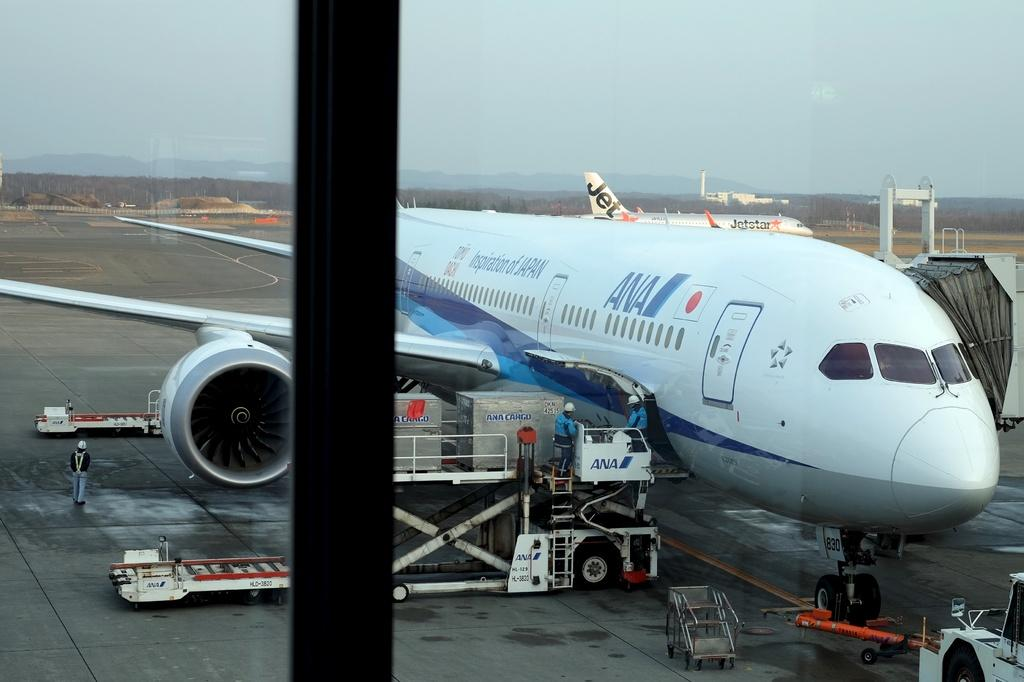What object is present in the image that can show reflections? There is a mirror in the image. What can be seen in the reflection of the mirror? The reflection of planes is visible in the mirror. What else is happening in the image besides the mirror and its reflection? There are people standing around in the image. How is the growth of the plants being distributed in the image? There are no plants present in the image, so the distribution of their growth cannot be determined. 